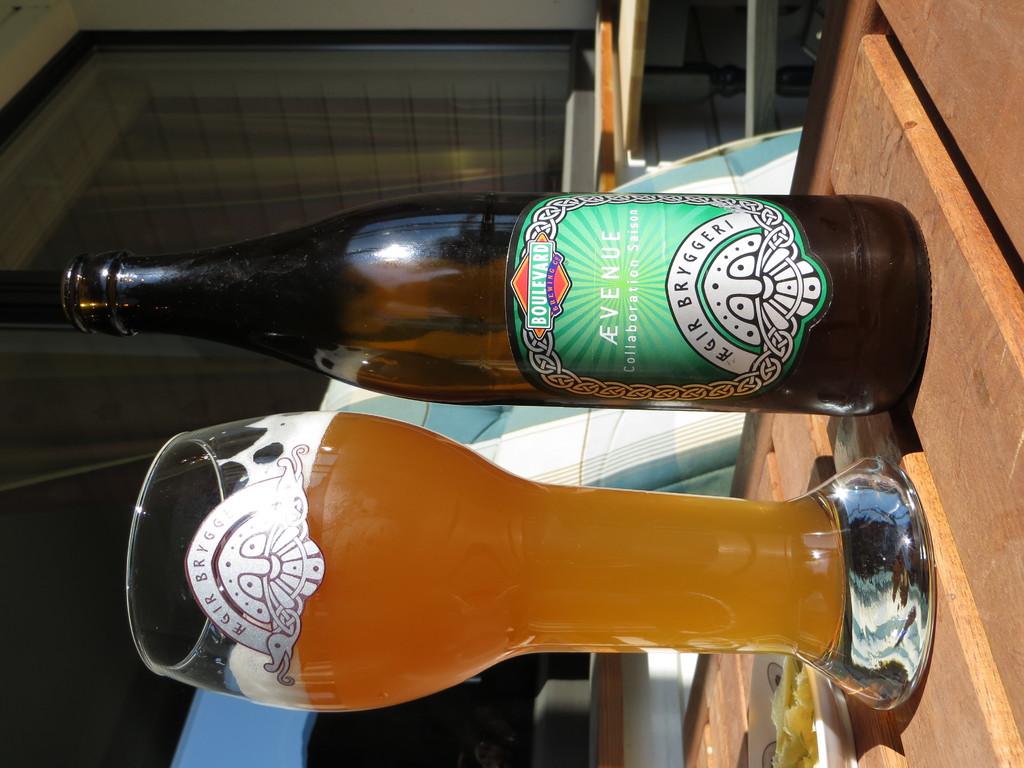What is the brand of beer?
Your response must be concise. Avenue. 